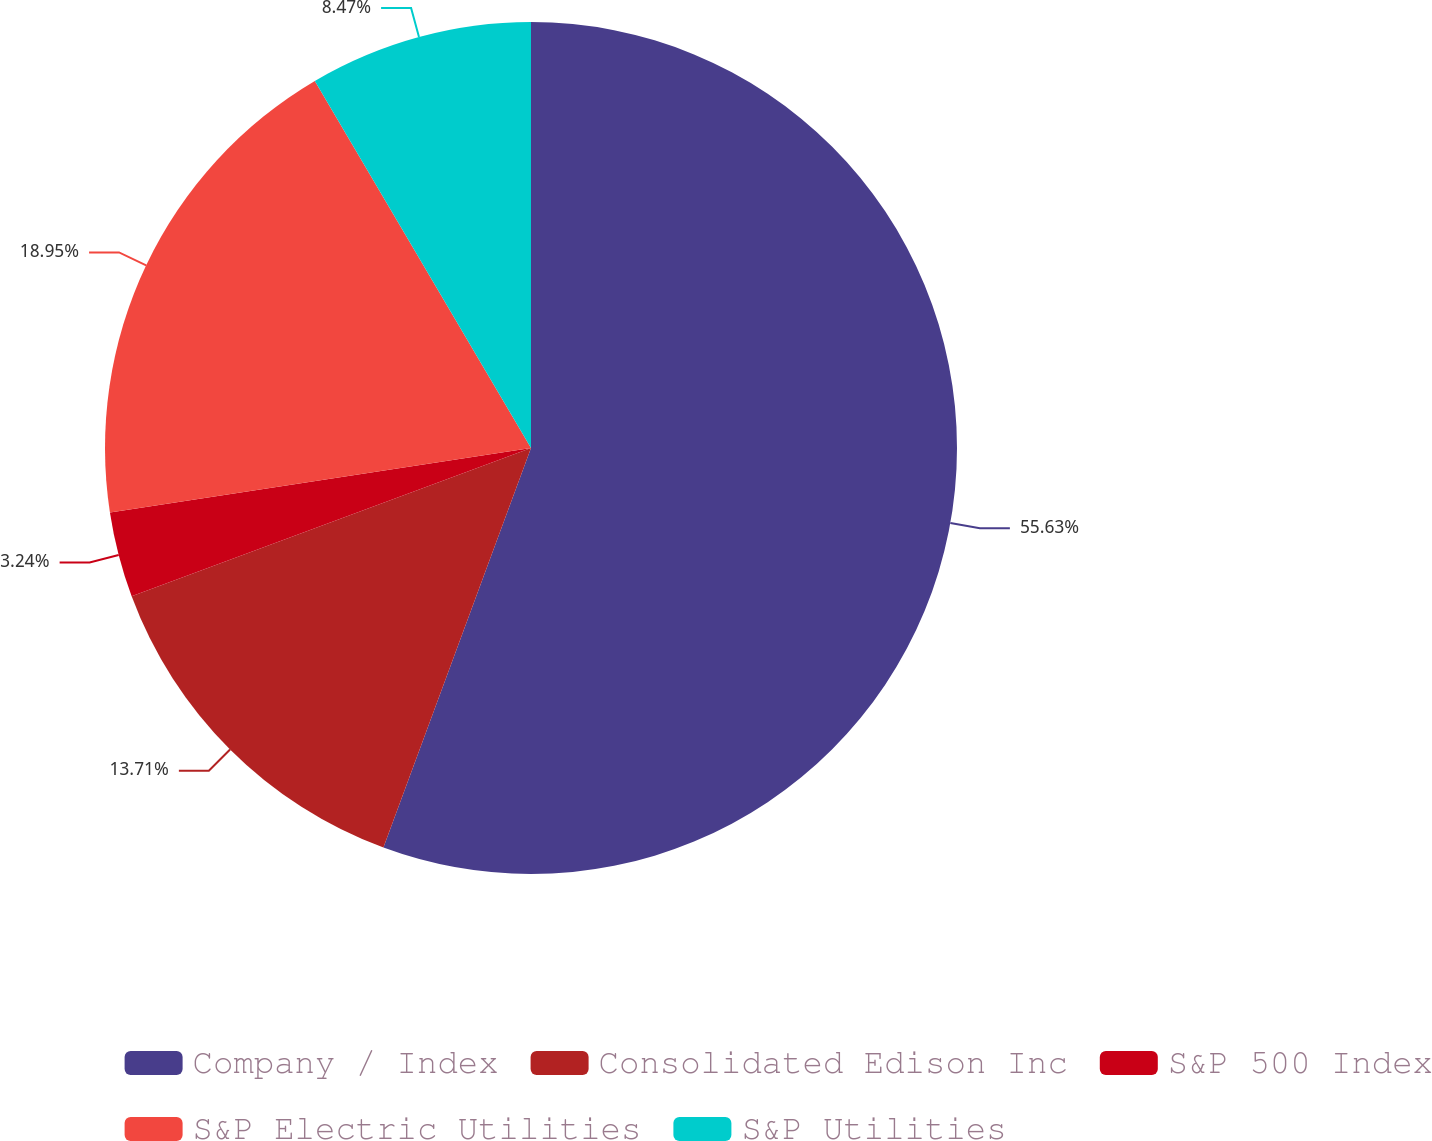Convert chart to OTSL. <chart><loc_0><loc_0><loc_500><loc_500><pie_chart><fcel>Company / Index<fcel>Consolidated Edison Inc<fcel>S&P 500 Index<fcel>S&P Electric Utilities<fcel>S&P Utilities<nl><fcel>55.63%<fcel>13.71%<fcel>3.24%<fcel>18.95%<fcel>8.47%<nl></chart> 